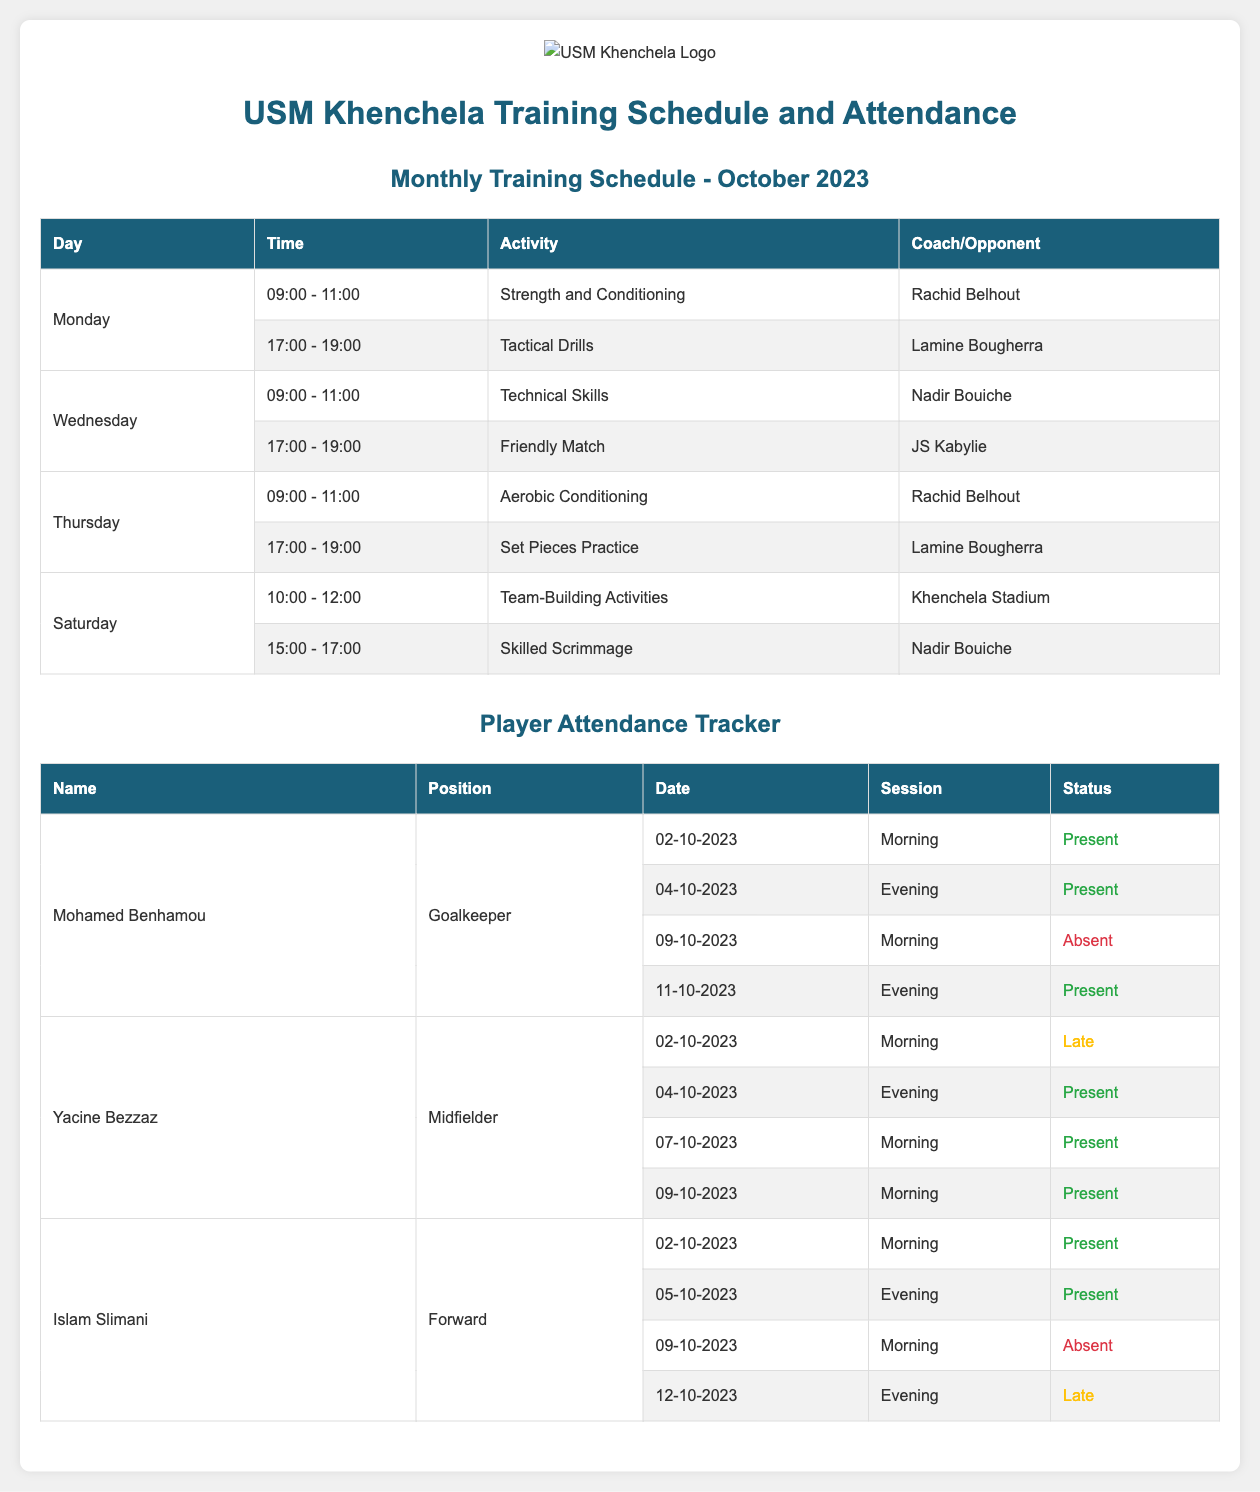What is the name of the goalkeeper? The goalkeeper's name is listed in the attendance section of the document.
Answer: Mohamed Benhamou What is the activity scheduled for Wednesday morning? The training activities on Wednesday morning can be found in the monthly schedule table.
Answer: Technical Skills Who is the coach for the Aerobic Conditioning session? The coach for Aerobic Conditioning is mentioned next to the respective activity in the schedule.
Answer: Rachid Belhout How many training sessions are scheduled on Monday? By counting the rows under Monday in the schedule section, we identify the number of sessions.
Answer: 2 What is the date when Yacine Bezzaz was late? The attendance table indicates when Yacine Bezzaz was late by providing dates and statuses.
Answer: 02-10-2023 Which opponent is scheduled for the friendly match? The friendly match opponent is mentioned under the tactical activities in the schedule.
Answer: JS Kabylie How many times did Islam Slimani attend training in the first half of October? The document shows attendance records for each date that Islam Slimani attended training.
Answer: 3 What is the duration of Team-Building Activities? The duration for Team-Building Activities can be found by analyzing the time slot in the schedule.
Answer: 2 hours What color represents 'Absent' in the attendance tracker? The color for 'Absent' is indicated in the attendance section by the status representation.
Answer: Red 